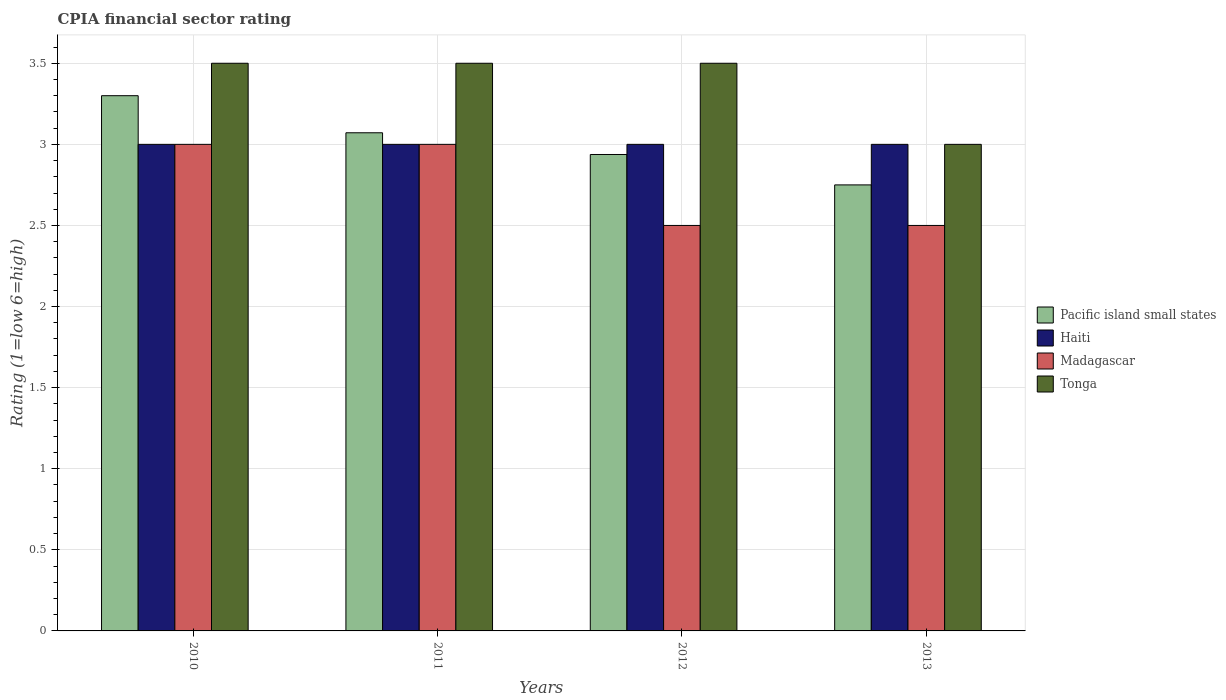How many groups of bars are there?
Offer a very short reply. 4. Are the number of bars per tick equal to the number of legend labels?
Offer a terse response. Yes. Are the number of bars on each tick of the X-axis equal?
Keep it short and to the point. Yes. In how many cases, is the number of bars for a given year not equal to the number of legend labels?
Provide a short and direct response. 0. What is the CPIA rating in Pacific island small states in 2011?
Your response must be concise. 3.07. Across all years, what is the maximum CPIA rating in Pacific island small states?
Provide a succinct answer. 3.3. Across all years, what is the minimum CPIA rating in Haiti?
Offer a very short reply. 3. In which year was the CPIA rating in Haiti maximum?
Your answer should be compact. 2010. What is the total CPIA rating in Pacific island small states in the graph?
Your response must be concise. 12.06. What is the difference between the CPIA rating in Pacific island small states in 2011 and that in 2012?
Offer a terse response. 0.13. What is the average CPIA rating in Tonga per year?
Keep it short and to the point. 3.38. In the year 2012, what is the difference between the CPIA rating in Tonga and CPIA rating in Pacific island small states?
Offer a very short reply. 0.56. In how many years, is the CPIA rating in Tonga greater than 3.1?
Ensure brevity in your answer.  3. Is the CPIA rating in Madagascar in 2011 less than that in 2012?
Offer a terse response. No. What is the difference between the highest and the lowest CPIA rating in Haiti?
Your answer should be very brief. 0. In how many years, is the CPIA rating in Tonga greater than the average CPIA rating in Tonga taken over all years?
Give a very brief answer. 3. What does the 1st bar from the left in 2013 represents?
Provide a succinct answer. Pacific island small states. What does the 3rd bar from the right in 2013 represents?
Provide a short and direct response. Haiti. Is it the case that in every year, the sum of the CPIA rating in Tonga and CPIA rating in Haiti is greater than the CPIA rating in Madagascar?
Your response must be concise. Yes. Are all the bars in the graph horizontal?
Your response must be concise. No. Are the values on the major ticks of Y-axis written in scientific E-notation?
Provide a short and direct response. No. Does the graph contain any zero values?
Your answer should be very brief. No. What is the title of the graph?
Provide a short and direct response. CPIA financial sector rating. What is the label or title of the Y-axis?
Your answer should be compact. Rating (1=low 6=high). What is the Rating (1=low 6=high) in Pacific island small states in 2010?
Offer a terse response. 3.3. What is the Rating (1=low 6=high) of Haiti in 2010?
Ensure brevity in your answer.  3. What is the Rating (1=low 6=high) of Madagascar in 2010?
Provide a succinct answer. 3. What is the Rating (1=low 6=high) of Pacific island small states in 2011?
Keep it short and to the point. 3.07. What is the Rating (1=low 6=high) of Haiti in 2011?
Provide a succinct answer. 3. What is the Rating (1=low 6=high) in Madagascar in 2011?
Offer a very short reply. 3. What is the Rating (1=low 6=high) in Tonga in 2011?
Your response must be concise. 3.5. What is the Rating (1=low 6=high) of Pacific island small states in 2012?
Offer a very short reply. 2.94. What is the Rating (1=low 6=high) of Pacific island small states in 2013?
Ensure brevity in your answer.  2.75. Across all years, what is the maximum Rating (1=low 6=high) of Pacific island small states?
Your answer should be compact. 3.3. Across all years, what is the maximum Rating (1=low 6=high) of Madagascar?
Offer a terse response. 3. Across all years, what is the maximum Rating (1=low 6=high) in Tonga?
Ensure brevity in your answer.  3.5. Across all years, what is the minimum Rating (1=low 6=high) in Pacific island small states?
Ensure brevity in your answer.  2.75. Across all years, what is the minimum Rating (1=low 6=high) of Haiti?
Provide a short and direct response. 3. Across all years, what is the minimum Rating (1=low 6=high) of Madagascar?
Make the answer very short. 2.5. What is the total Rating (1=low 6=high) of Pacific island small states in the graph?
Provide a succinct answer. 12.06. What is the total Rating (1=low 6=high) of Tonga in the graph?
Make the answer very short. 13.5. What is the difference between the Rating (1=low 6=high) in Pacific island small states in 2010 and that in 2011?
Ensure brevity in your answer.  0.23. What is the difference between the Rating (1=low 6=high) in Tonga in 2010 and that in 2011?
Your answer should be very brief. 0. What is the difference between the Rating (1=low 6=high) of Pacific island small states in 2010 and that in 2012?
Make the answer very short. 0.36. What is the difference between the Rating (1=low 6=high) of Haiti in 2010 and that in 2012?
Offer a very short reply. 0. What is the difference between the Rating (1=low 6=high) of Madagascar in 2010 and that in 2012?
Your response must be concise. 0.5. What is the difference between the Rating (1=low 6=high) of Tonga in 2010 and that in 2012?
Provide a succinct answer. 0. What is the difference between the Rating (1=low 6=high) in Pacific island small states in 2010 and that in 2013?
Your answer should be very brief. 0.55. What is the difference between the Rating (1=low 6=high) of Haiti in 2010 and that in 2013?
Your answer should be compact. 0. What is the difference between the Rating (1=low 6=high) of Madagascar in 2010 and that in 2013?
Make the answer very short. 0.5. What is the difference between the Rating (1=low 6=high) of Tonga in 2010 and that in 2013?
Offer a very short reply. 0.5. What is the difference between the Rating (1=low 6=high) of Pacific island small states in 2011 and that in 2012?
Offer a terse response. 0.13. What is the difference between the Rating (1=low 6=high) in Pacific island small states in 2011 and that in 2013?
Ensure brevity in your answer.  0.32. What is the difference between the Rating (1=low 6=high) of Haiti in 2011 and that in 2013?
Keep it short and to the point. 0. What is the difference between the Rating (1=low 6=high) of Madagascar in 2011 and that in 2013?
Your answer should be compact. 0.5. What is the difference between the Rating (1=low 6=high) in Pacific island small states in 2012 and that in 2013?
Offer a terse response. 0.19. What is the difference between the Rating (1=low 6=high) of Haiti in 2012 and that in 2013?
Provide a short and direct response. 0. What is the difference between the Rating (1=low 6=high) of Madagascar in 2012 and that in 2013?
Ensure brevity in your answer.  0. What is the difference between the Rating (1=low 6=high) in Pacific island small states in 2010 and the Rating (1=low 6=high) in Tonga in 2011?
Your answer should be very brief. -0.2. What is the difference between the Rating (1=low 6=high) of Haiti in 2010 and the Rating (1=low 6=high) of Madagascar in 2011?
Your answer should be compact. 0. What is the difference between the Rating (1=low 6=high) in Haiti in 2010 and the Rating (1=low 6=high) in Tonga in 2011?
Keep it short and to the point. -0.5. What is the difference between the Rating (1=low 6=high) of Madagascar in 2010 and the Rating (1=low 6=high) of Tonga in 2011?
Ensure brevity in your answer.  -0.5. What is the difference between the Rating (1=low 6=high) of Pacific island small states in 2010 and the Rating (1=low 6=high) of Madagascar in 2012?
Give a very brief answer. 0.8. What is the difference between the Rating (1=low 6=high) of Haiti in 2010 and the Rating (1=low 6=high) of Tonga in 2012?
Make the answer very short. -0.5. What is the difference between the Rating (1=low 6=high) in Pacific island small states in 2011 and the Rating (1=low 6=high) in Haiti in 2012?
Ensure brevity in your answer.  0.07. What is the difference between the Rating (1=low 6=high) in Pacific island small states in 2011 and the Rating (1=low 6=high) in Tonga in 2012?
Your answer should be very brief. -0.43. What is the difference between the Rating (1=low 6=high) of Haiti in 2011 and the Rating (1=low 6=high) of Madagascar in 2012?
Offer a terse response. 0.5. What is the difference between the Rating (1=low 6=high) of Pacific island small states in 2011 and the Rating (1=low 6=high) of Haiti in 2013?
Make the answer very short. 0.07. What is the difference between the Rating (1=low 6=high) of Pacific island small states in 2011 and the Rating (1=low 6=high) of Madagascar in 2013?
Provide a succinct answer. 0.57. What is the difference between the Rating (1=low 6=high) in Pacific island small states in 2011 and the Rating (1=low 6=high) in Tonga in 2013?
Your response must be concise. 0.07. What is the difference between the Rating (1=low 6=high) of Haiti in 2011 and the Rating (1=low 6=high) of Tonga in 2013?
Your answer should be compact. 0. What is the difference between the Rating (1=low 6=high) in Pacific island small states in 2012 and the Rating (1=low 6=high) in Haiti in 2013?
Provide a short and direct response. -0.06. What is the difference between the Rating (1=low 6=high) in Pacific island small states in 2012 and the Rating (1=low 6=high) in Madagascar in 2013?
Provide a succinct answer. 0.44. What is the difference between the Rating (1=low 6=high) in Pacific island small states in 2012 and the Rating (1=low 6=high) in Tonga in 2013?
Your response must be concise. -0.06. What is the difference between the Rating (1=low 6=high) of Haiti in 2012 and the Rating (1=low 6=high) of Madagascar in 2013?
Keep it short and to the point. 0.5. What is the difference between the Rating (1=low 6=high) of Haiti in 2012 and the Rating (1=low 6=high) of Tonga in 2013?
Provide a succinct answer. 0. What is the difference between the Rating (1=low 6=high) of Madagascar in 2012 and the Rating (1=low 6=high) of Tonga in 2013?
Your answer should be very brief. -0.5. What is the average Rating (1=low 6=high) of Pacific island small states per year?
Your response must be concise. 3.01. What is the average Rating (1=low 6=high) of Haiti per year?
Offer a very short reply. 3. What is the average Rating (1=low 6=high) of Madagascar per year?
Provide a succinct answer. 2.75. What is the average Rating (1=low 6=high) in Tonga per year?
Provide a succinct answer. 3.38. In the year 2010, what is the difference between the Rating (1=low 6=high) in Pacific island small states and Rating (1=low 6=high) in Haiti?
Your answer should be very brief. 0.3. In the year 2010, what is the difference between the Rating (1=low 6=high) of Pacific island small states and Rating (1=low 6=high) of Madagascar?
Offer a very short reply. 0.3. In the year 2010, what is the difference between the Rating (1=low 6=high) in Pacific island small states and Rating (1=low 6=high) in Tonga?
Give a very brief answer. -0.2. In the year 2010, what is the difference between the Rating (1=low 6=high) in Haiti and Rating (1=low 6=high) in Madagascar?
Provide a succinct answer. 0. In the year 2010, what is the difference between the Rating (1=low 6=high) in Madagascar and Rating (1=low 6=high) in Tonga?
Provide a short and direct response. -0.5. In the year 2011, what is the difference between the Rating (1=low 6=high) in Pacific island small states and Rating (1=low 6=high) in Haiti?
Give a very brief answer. 0.07. In the year 2011, what is the difference between the Rating (1=low 6=high) in Pacific island small states and Rating (1=low 6=high) in Madagascar?
Offer a very short reply. 0.07. In the year 2011, what is the difference between the Rating (1=low 6=high) in Pacific island small states and Rating (1=low 6=high) in Tonga?
Offer a very short reply. -0.43. In the year 2011, what is the difference between the Rating (1=low 6=high) in Haiti and Rating (1=low 6=high) in Tonga?
Ensure brevity in your answer.  -0.5. In the year 2012, what is the difference between the Rating (1=low 6=high) of Pacific island small states and Rating (1=low 6=high) of Haiti?
Provide a succinct answer. -0.06. In the year 2012, what is the difference between the Rating (1=low 6=high) of Pacific island small states and Rating (1=low 6=high) of Madagascar?
Keep it short and to the point. 0.44. In the year 2012, what is the difference between the Rating (1=low 6=high) in Pacific island small states and Rating (1=low 6=high) in Tonga?
Offer a terse response. -0.56. In the year 2013, what is the difference between the Rating (1=low 6=high) of Haiti and Rating (1=low 6=high) of Madagascar?
Your response must be concise. 0.5. In the year 2013, what is the difference between the Rating (1=low 6=high) in Haiti and Rating (1=low 6=high) in Tonga?
Your answer should be very brief. 0. In the year 2013, what is the difference between the Rating (1=low 6=high) of Madagascar and Rating (1=low 6=high) of Tonga?
Make the answer very short. -0.5. What is the ratio of the Rating (1=low 6=high) in Pacific island small states in 2010 to that in 2011?
Your answer should be compact. 1.07. What is the ratio of the Rating (1=low 6=high) of Madagascar in 2010 to that in 2011?
Ensure brevity in your answer.  1. What is the ratio of the Rating (1=low 6=high) of Pacific island small states in 2010 to that in 2012?
Keep it short and to the point. 1.12. What is the ratio of the Rating (1=low 6=high) of Madagascar in 2010 to that in 2012?
Keep it short and to the point. 1.2. What is the ratio of the Rating (1=low 6=high) of Haiti in 2010 to that in 2013?
Offer a very short reply. 1. What is the ratio of the Rating (1=low 6=high) in Pacific island small states in 2011 to that in 2012?
Ensure brevity in your answer.  1.05. What is the ratio of the Rating (1=low 6=high) in Pacific island small states in 2011 to that in 2013?
Your answer should be very brief. 1.12. What is the ratio of the Rating (1=low 6=high) in Tonga in 2011 to that in 2013?
Keep it short and to the point. 1.17. What is the ratio of the Rating (1=low 6=high) of Pacific island small states in 2012 to that in 2013?
Offer a terse response. 1.07. What is the ratio of the Rating (1=low 6=high) in Haiti in 2012 to that in 2013?
Make the answer very short. 1. What is the ratio of the Rating (1=low 6=high) of Tonga in 2012 to that in 2013?
Keep it short and to the point. 1.17. What is the difference between the highest and the second highest Rating (1=low 6=high) of Pacific island small states?
Provide a short and direct response. 0.23. What is the difference between the highest and the second highest Rating (1=low 6=high) of Haiti?
Make the answer very short. 0. What is the difference between the highest and the second highest Rating (1=low 6=high) of Madagascar?
Your answer should be very brief. 0. What is the difference between the highest and the lowest Rating (1=low 6=high) of Pacific island small states?
Offer a terse response. 0.55. 